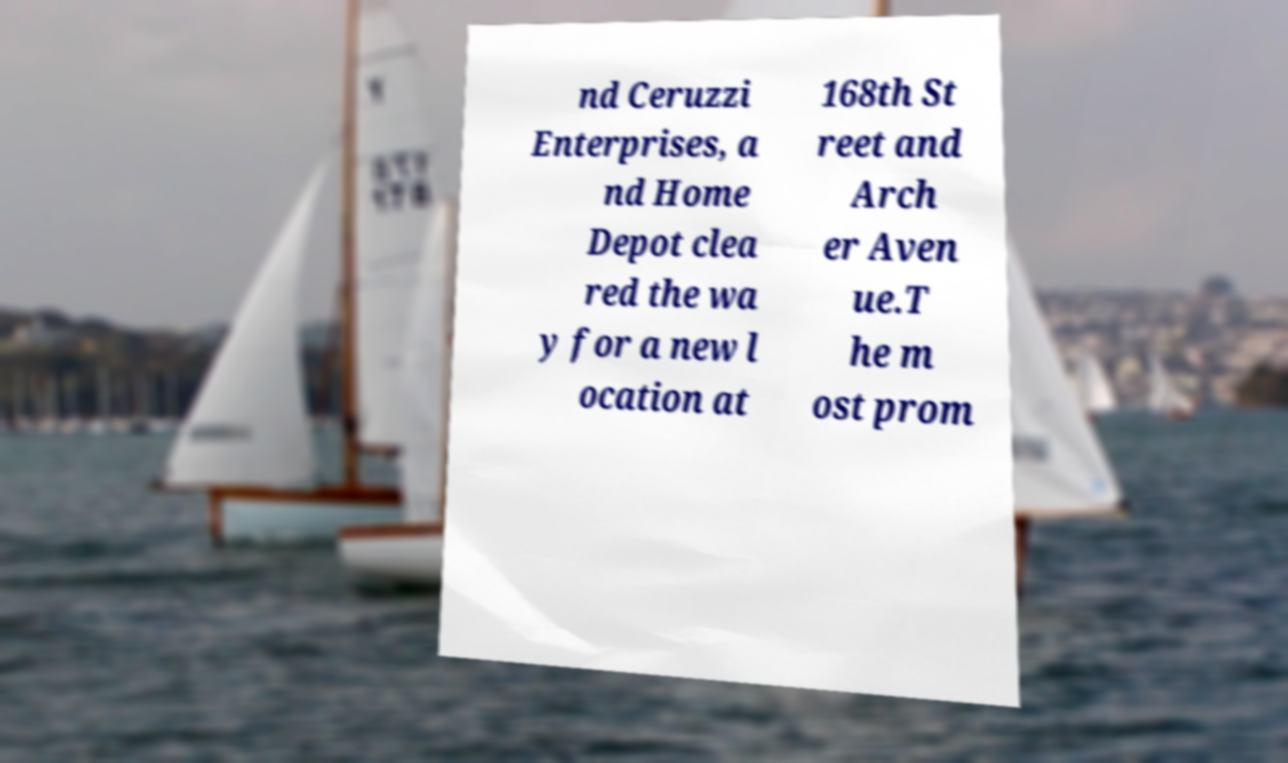Could you assist in decoding the text presented in this image and type it out clearly? nd Ceruzzi Enterprises, a nd Home Depot clea red the wa y for a new l ocation at 168th St reet and Arch er Aven ue.T he m ost prom 